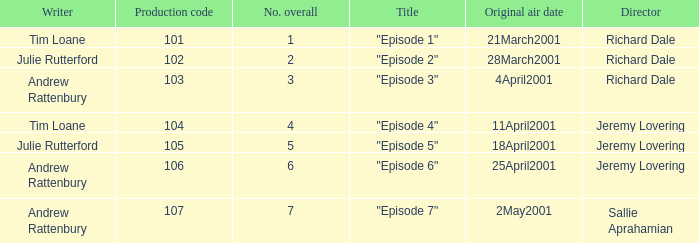What is the highest production code of an episode written by Tim Loane? 104.0. 